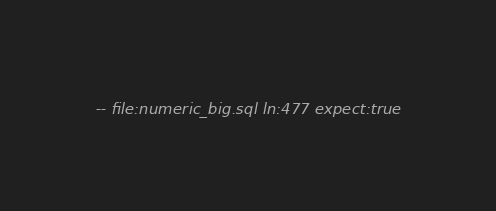<code> <loc_0><loc_0><loc_500><loc_500><_SQL_>-- file:numeric_big.sql ln:477 expect:true</code> 